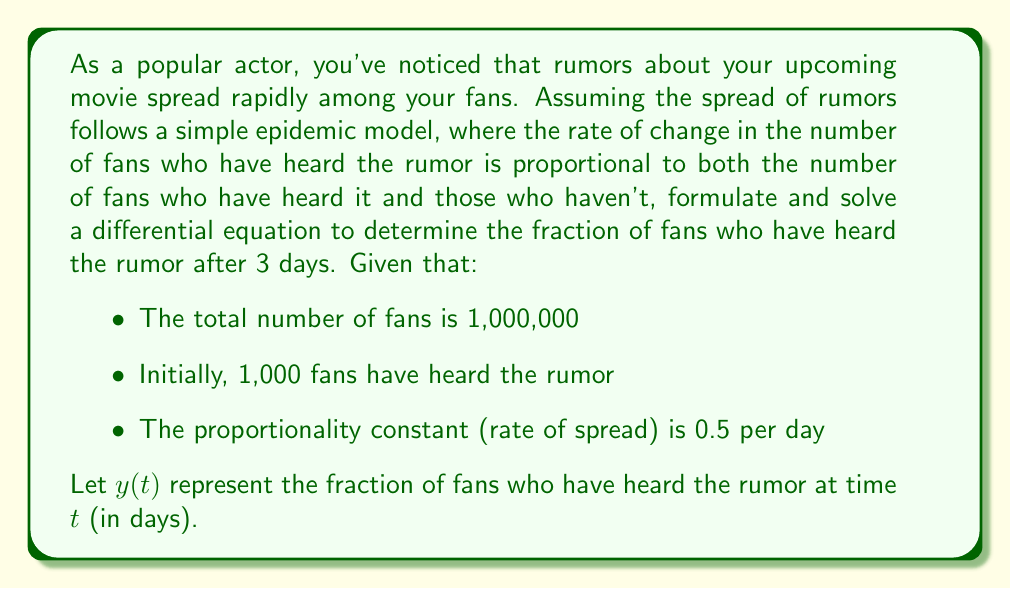Help me with this question. To solve this problem, we'll use the logistic growth model, which is a simple epidemic model. Let's break it down step-by-step:

1) The differential equation for this model is:

   $$\frac{dy}{dt} = ky(1-y)$$

   where $k$ is the proportionality constant (rate of spread).

2) We're given that $k = 0.5$ per day, so our equation becomes:

   $$\frac{dy}{dt} = 0.5y(1-y)$$

3) The initial condition is:

   $$y(0) = \frac{1,000}{1,000,000} = 0.001$$

4) To solve this differential equation, we can use separation of variables:

   $$\int \frac{dy}{y(1-y)} = \int 0.5 dt$$

5) The left side can be decomposed using partial fractions:

   $$\int (\frac{1}{y} + \frac{1}{1-y}) dy = 0.5t + C$$

6) Integrating both sides:

   $$\ln|y| - \ln|1-y| = 0.5t + C$$

7) Simplifying and applying the exponential function to both sides:

   $$\frac{y}{1-y} = Ce^{0.5t}$$

8) Solving for $y$:

   $$y = \frac{Ce^{0.5t}}{1+Ce^{0.5t}}$$

9) Using the initial condition $y(0) = 0.001$ to find $C$:

   $$0.001 = \frac{C}{1+C}$$
   $$C = \frac{0.001}{0.999} \approx 0.001001$$

10) Our final solution is:

    $$y(t) = \frac{0.001001e^{0.5t}}{1+0.001001e^{0.5t}}$$

11) To find $y(3)$, we plug in $t=3$:

    $$y(3) = \frac{0.001001e^{1.5}}{1+0.001001e^{1.5}} \approx 0.0183$$

Therefore, after 3 days, approximately 1.83% of fans have heard the rumor.
Answer: After 3 days, approximately 1.83% of fans have heard the rumor. 